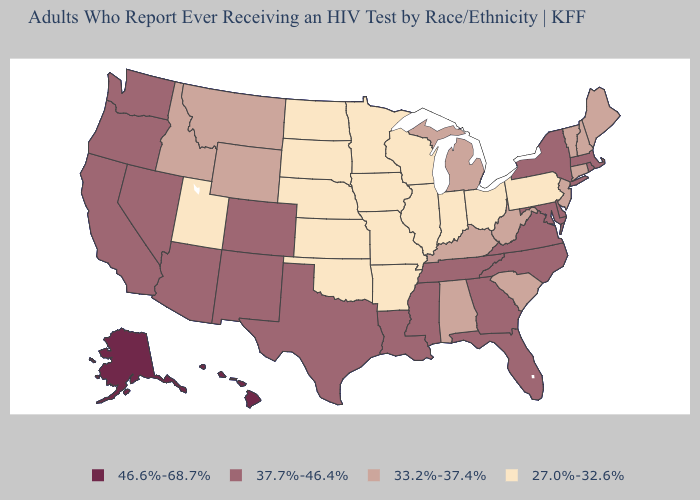Does the map have missing data?
Short answer required. No. Does Minnesota have the lowest value in the USA?
Concise answer only. Yes. What is the value of Maine?
Answer briefly. 33.2%-37.4%. Does Utah have the lowest value in the USA?
Short answer required. Yes. What is the value of Florida?
Quick response, please. 37.7%-46.4%. What is the lowest value in states that border Rhode Island?
Be succinct. 33.2%-37.4%. What is the value of Rhode Island?
Give a very brief answer. 37.7%-46.4%. Does Iowa have the highest value in the MidWest?
Be succinct. No. Name the states that have a value in the range 46.6%-68.7%?
Concise answer only. Alaska, Hawaii. Name the states that have a value in the range 37.7%-46.4%?
Answer briefly. Arizona, California, Colorado, Delaware, Florida, Georgia, Louisiana, Maryland, Massachusetts, Mississippi, Nevada, New Mexico, New York, North Carolina, Oregon, Rhode Island, Tennessee, Texas, Virginia, Washington. What is the lowest value in the USA?
Keep it brief. 27.0%-32.6%. Name the states that have a value in the range 37.7%-46.4%?
Concise answer only. Arizona, California, Colorado, Delaware, Florida, Georgia, Louisiana, Maryland, Massachusetts, Mississippi, Nevada, New Mexico, New York, North Carolina, Oregon, Rhode Island, Tennessee, Texas, Virginia, Washington. What is the value of South Carolina?
Give a very brief answer. 33.2%-37.4%. Among the states that border New York , does Massachusetts have the highest value?
Give a very brief answer. Yes. What is the value of Colorado?
Answer briefly. 37.7%-46.4%. 